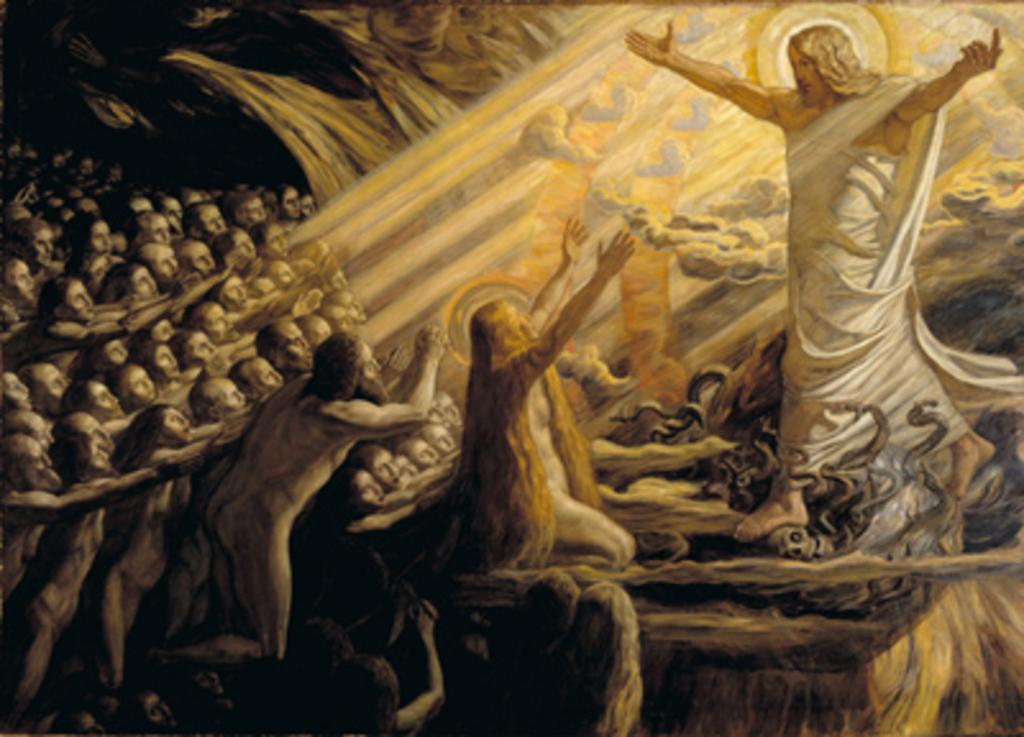What type of artwork is depicted in the image? The image is a painting. What can be seen in the painting? There is a group of people in the painting. Are there any objects present in the painting? Yes, there are objects present in the painting. What color is the vest worn by the person driving the truck in the painting? There is no truck or person wearing a vest in the painting; it only features a group of people and objects. 